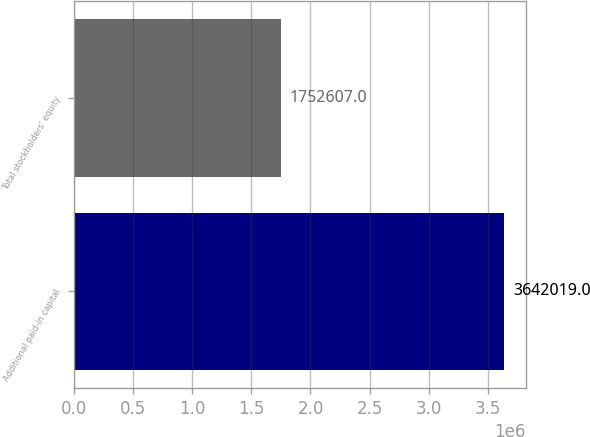<chart> <loc_0><loc_0><loc_500><loc_500><bar_chart><fcel>Additional paid-in capital<fcel>Total stockholders' equity<nl><fcel>3.64202e+06<fcel>1.75261e+06<nl></chart> 